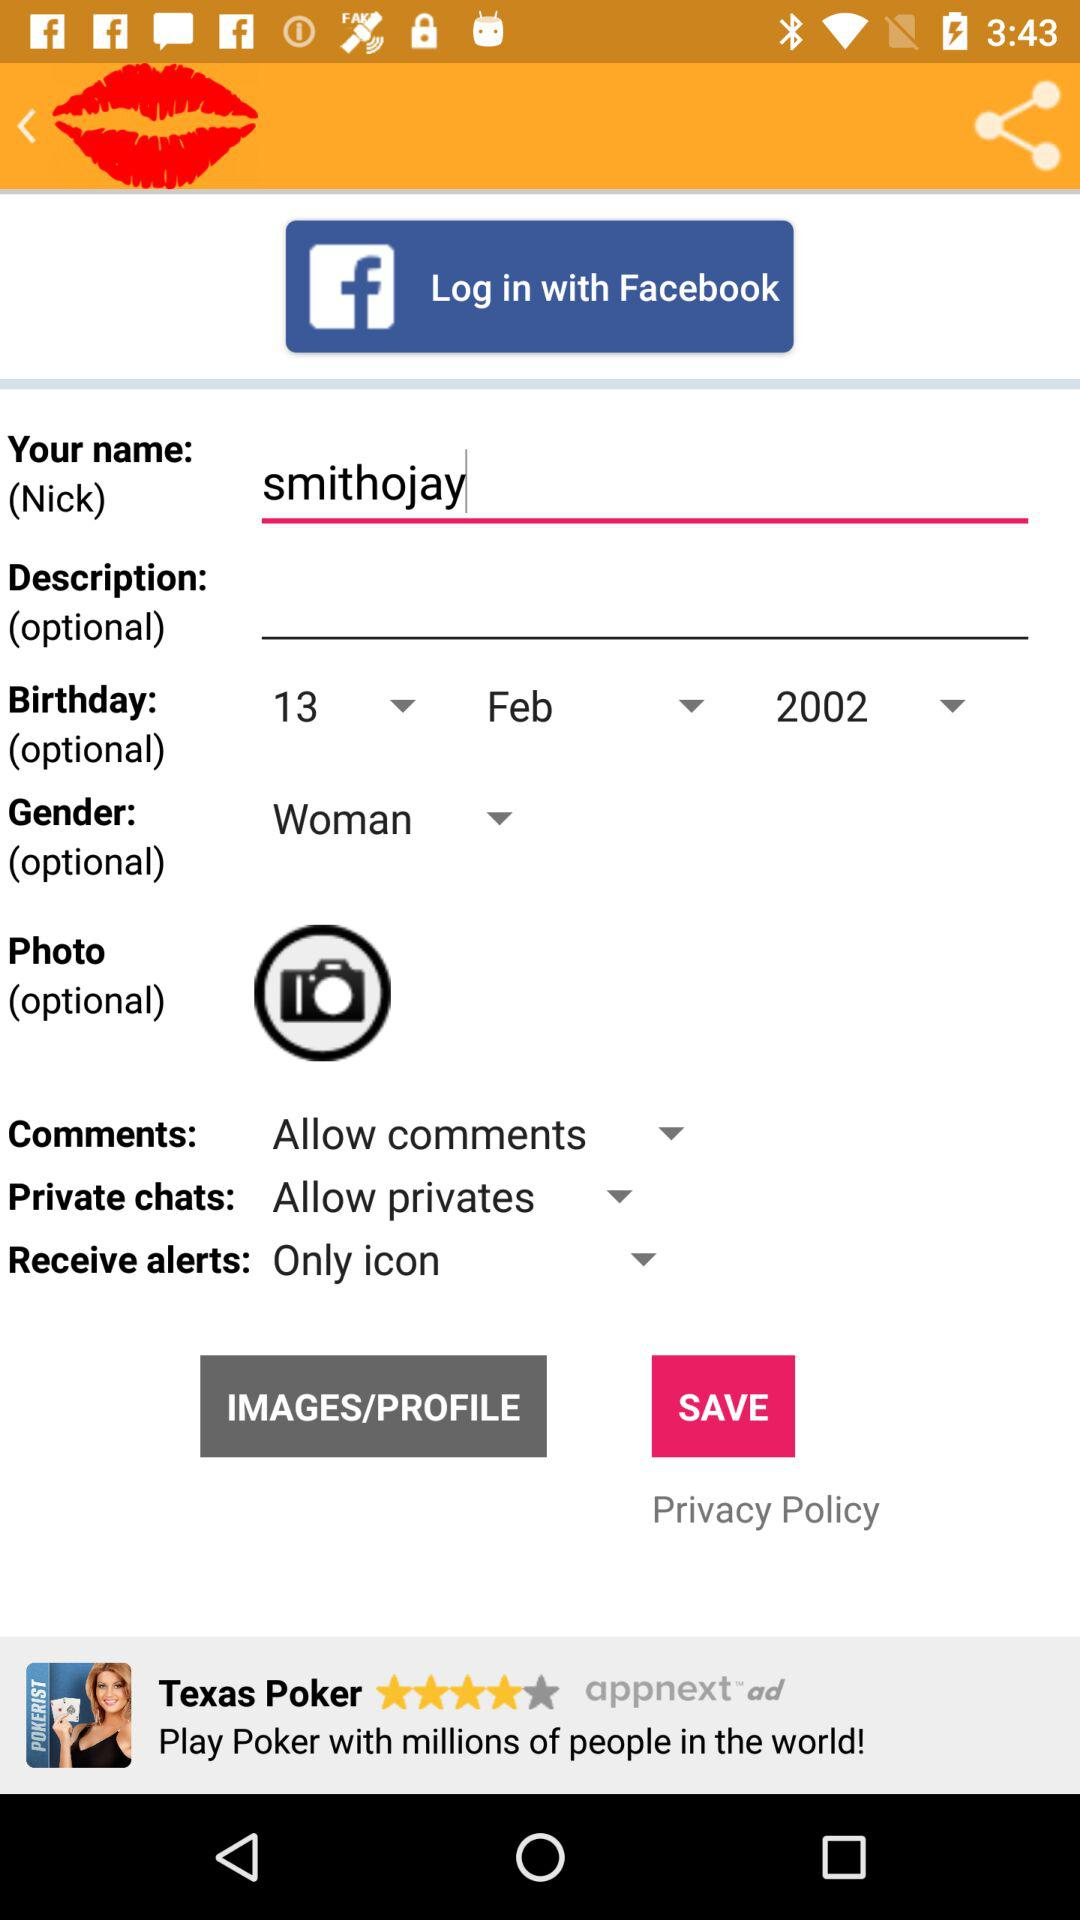Is the photo compulsory or optional? The photo is optional. 